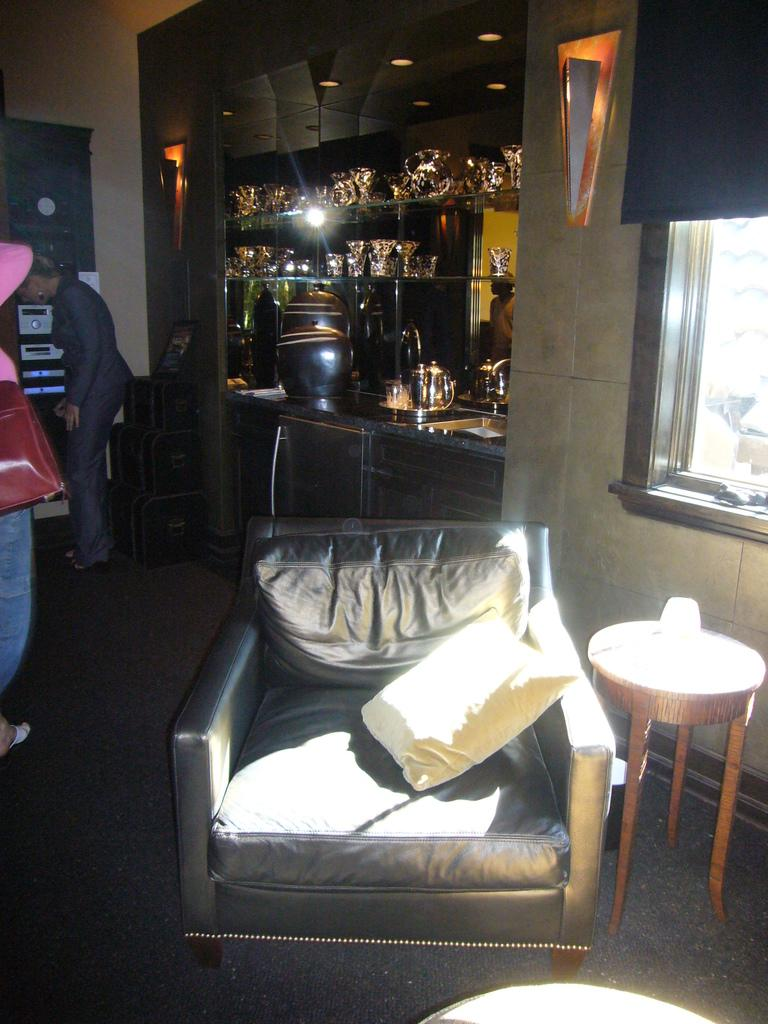What type of surface is visible in the image? There is a floor in the image. What type of furniture is present in the image? There is a couch in the image. What type of seating accessory is present in the image? There is a cushion in the image. What type of surface is used for placing objects in the image? There is a table in the image. What type of people are present in the image? There are persons standing in the image. What type of storage is present in the image? There are racks with metal objects in the image. What type of illumination is present in the image? There are lights in the image. What type of barrier is present in the image? There is a wall in the image. What type of opening is present in the wall in the image? There is a window in the image. What type of mouth can be seen on the tent in the image? There is no tent present in the image, and therefore no mouth can be seen on it. What type of hospital is visible in the image? There is no hospital present in the image. 